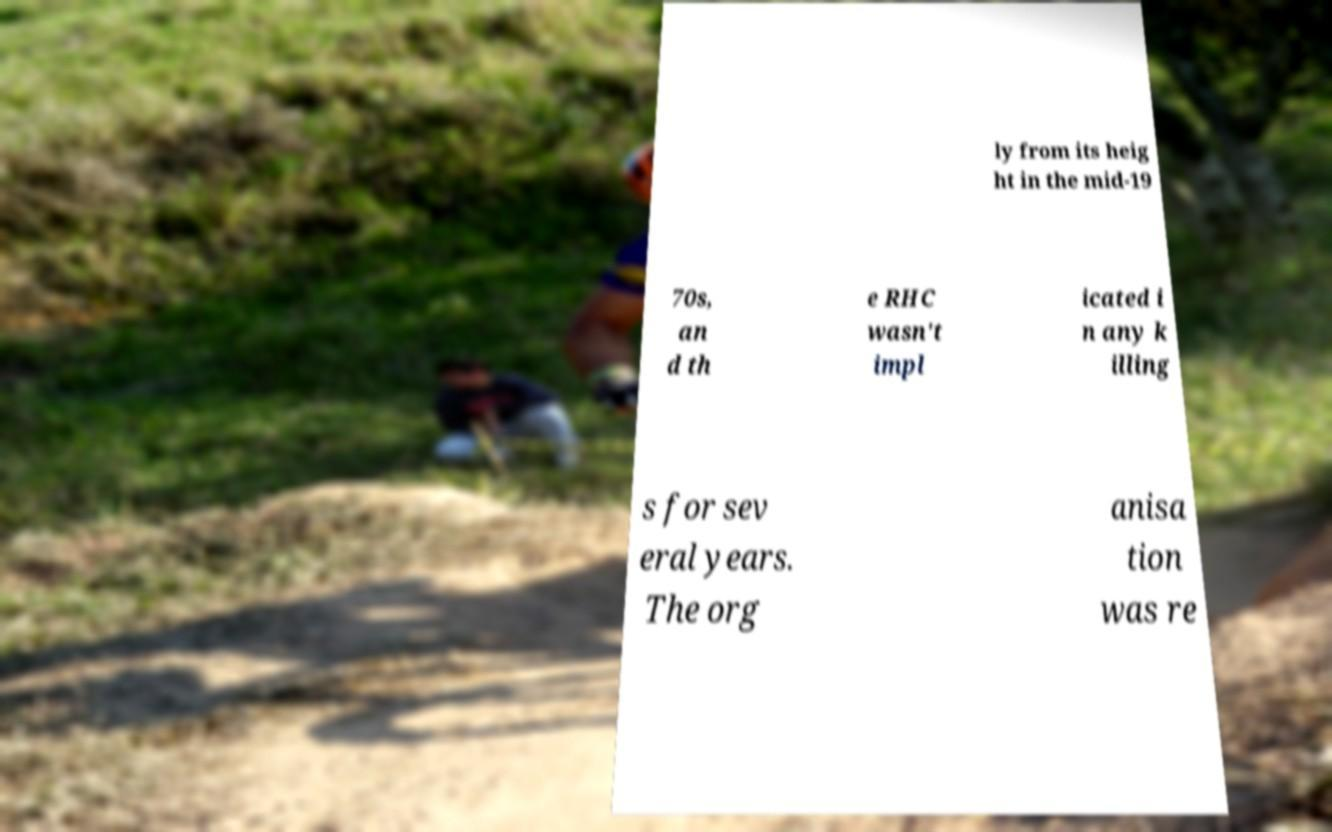Can you accurately transcribe the text from the provided image for me? ly from its heig ht in the mid-19 70s, an d th e RHC wasn't impl icated i n any k illing s for sev eral years. The org anisa tion was re 